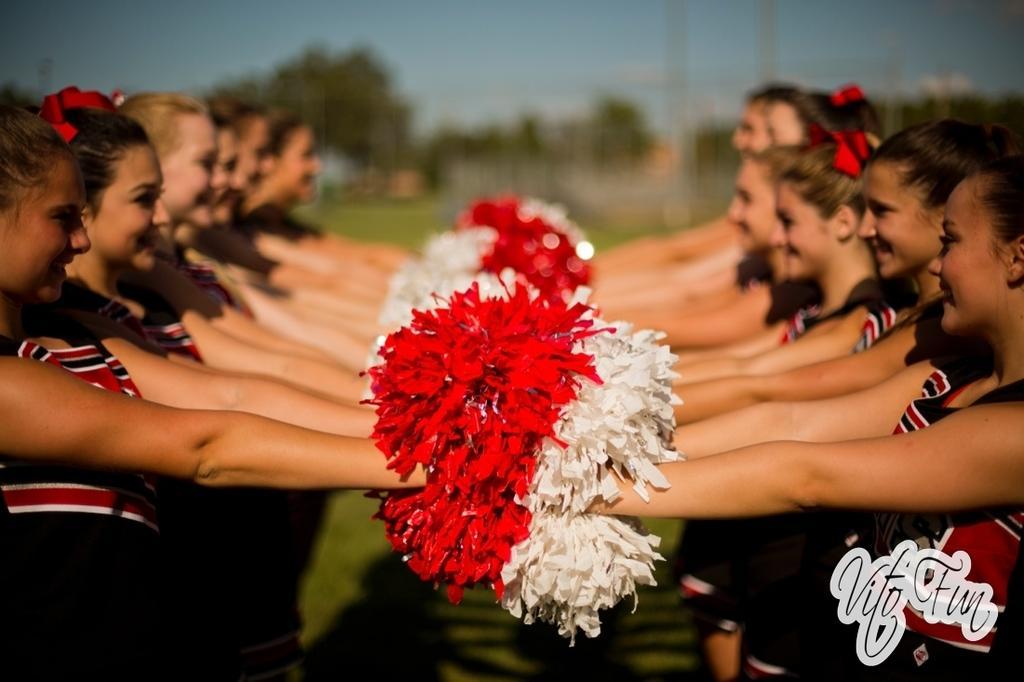Can you describe this image briefly? In this image we can see some people standing and holding some objects in their hands and there are some trees and in the background, the image is blurred. 